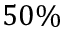Convert formula to latex. <formula><loc_0><loc_0><loc_500><loc_500>5 0 \%</formula> 